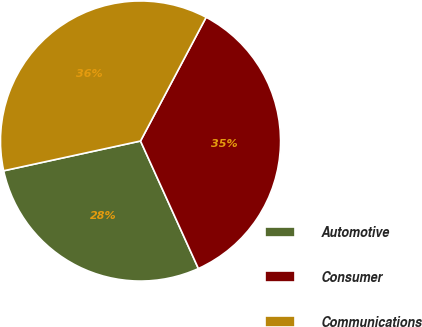Convert chart. <chart><loc_0><loc_0><loc_500><loc_500><pie_chart><fcel>Automotive<fcel>Consumer<fcel>Communications<nl><fcel>28.37%<fcel>35.46%<fcel>36.17%<nl></chart> 